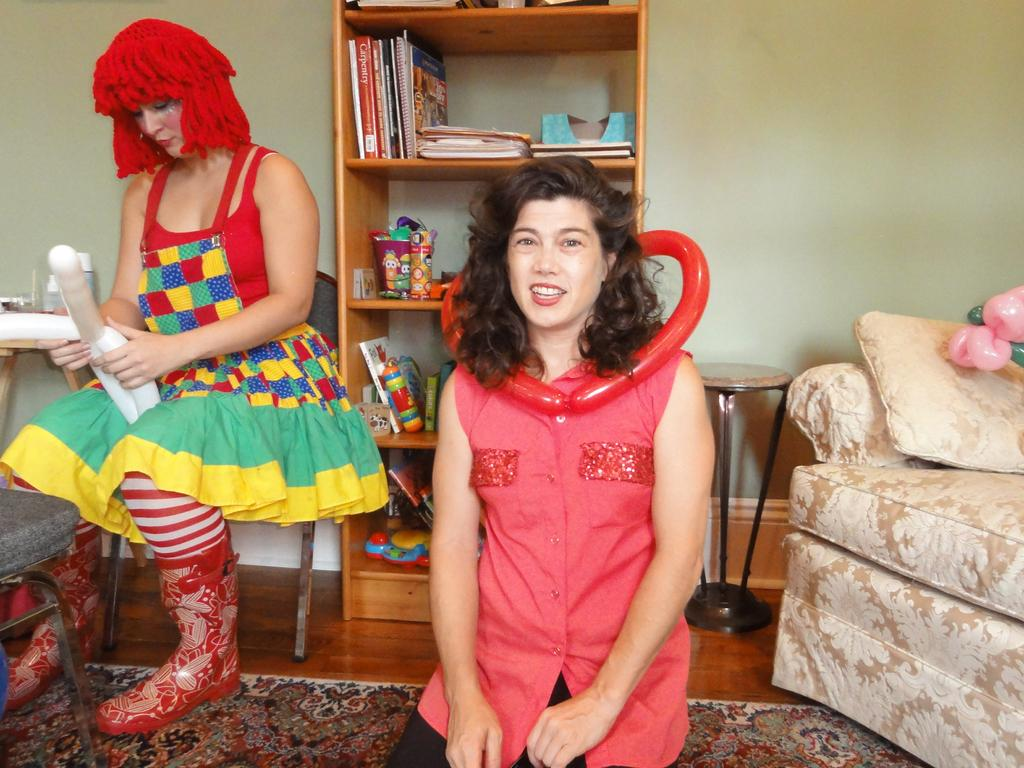How many women are present in the image? There are two women in the image. What can be seen in the background of the image? Bookshelves and a couch are visible in the background. What type of furniture is present in the image? There is a chair in the image. How many oranges are on the chair in the image? There are no oranges present in the image; only a chair is visible. 